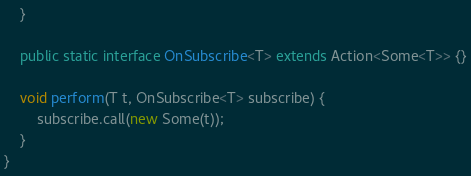Convert code to text. <code><loc_0><loc_0><loc_500><loc_500><_Java_>    }

    public static interface OnSubscribe<T> extends Action<Some<T>> {}

    void perform(T t, OnSubscribe<T> subscribe) {
        subscribe.call(new Some(t));
    }
}
</code> 